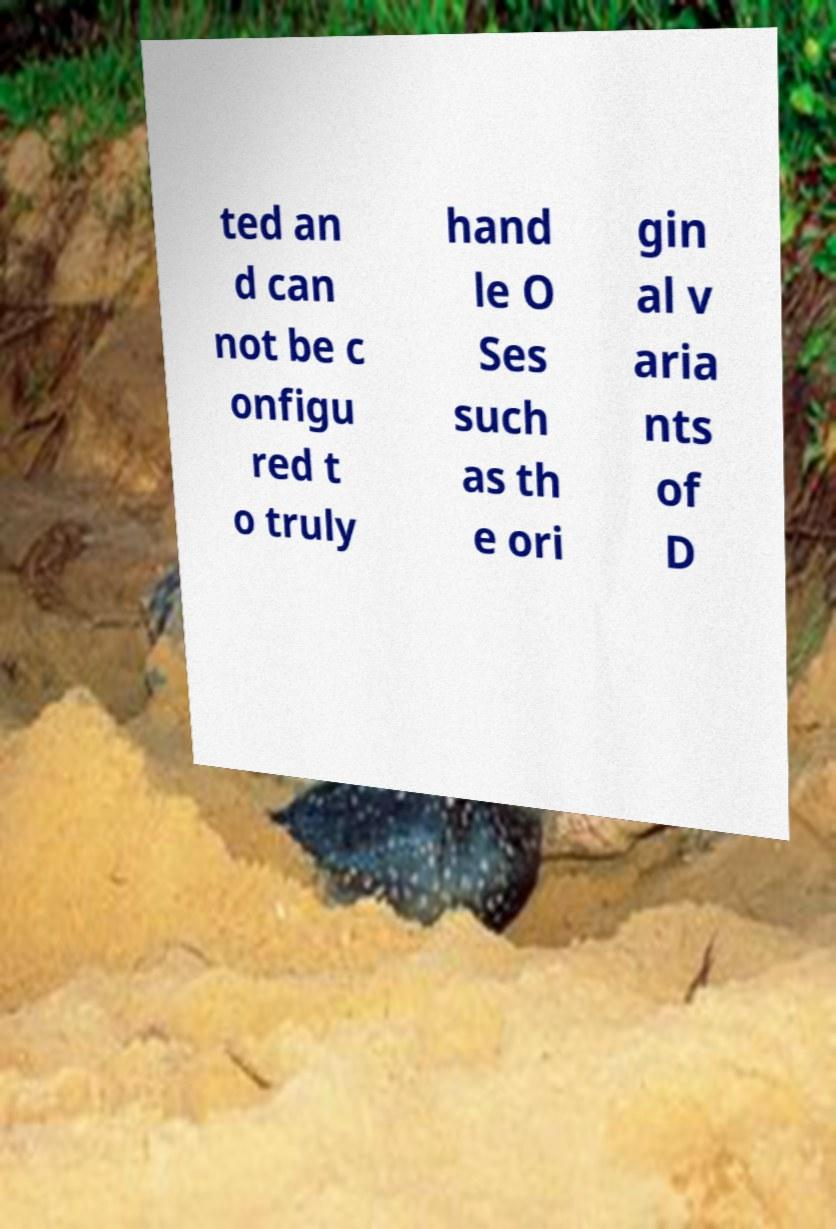Please read and relay the text visible in this image. What does it say? ted an d can not be c onfigu red t o truly hand le O Ses such as th e ori gin al v aria nts of D 